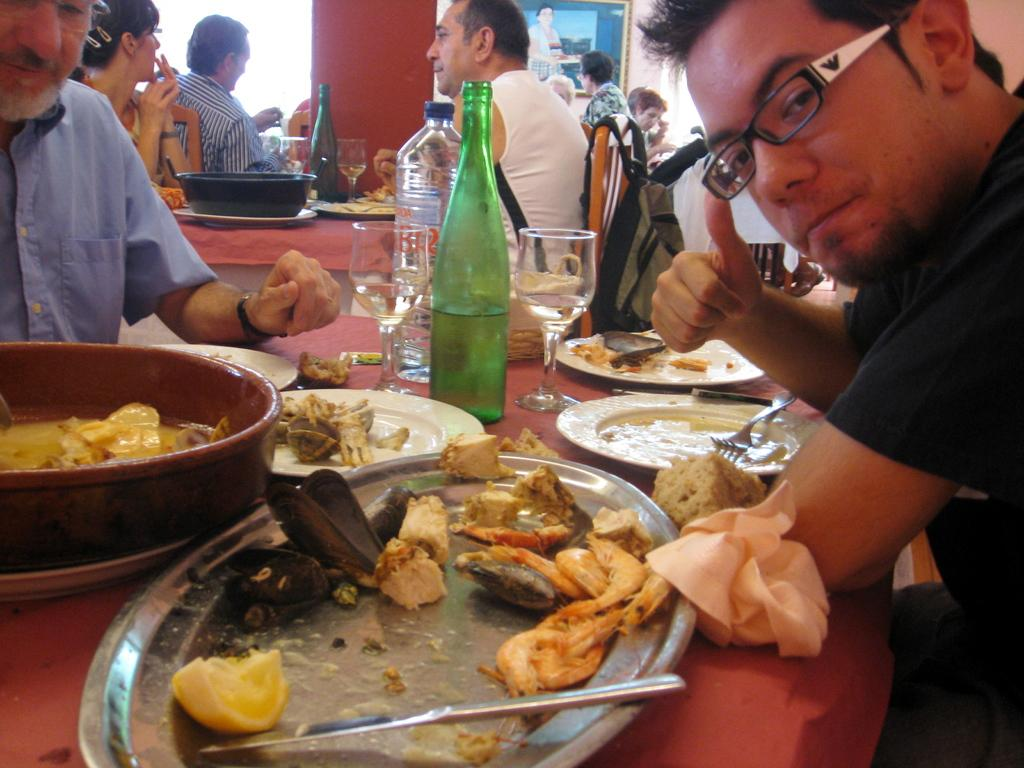How many people are in the image? There is a group of persons in the image. What are the persons doing in the image? The persons are sitting on chairs, having drinks, and having food. What type of cave can be seen in the background of the image? There is no cave present in the image; it features a group of persons sitting on chairs, having drinks, and having food. 